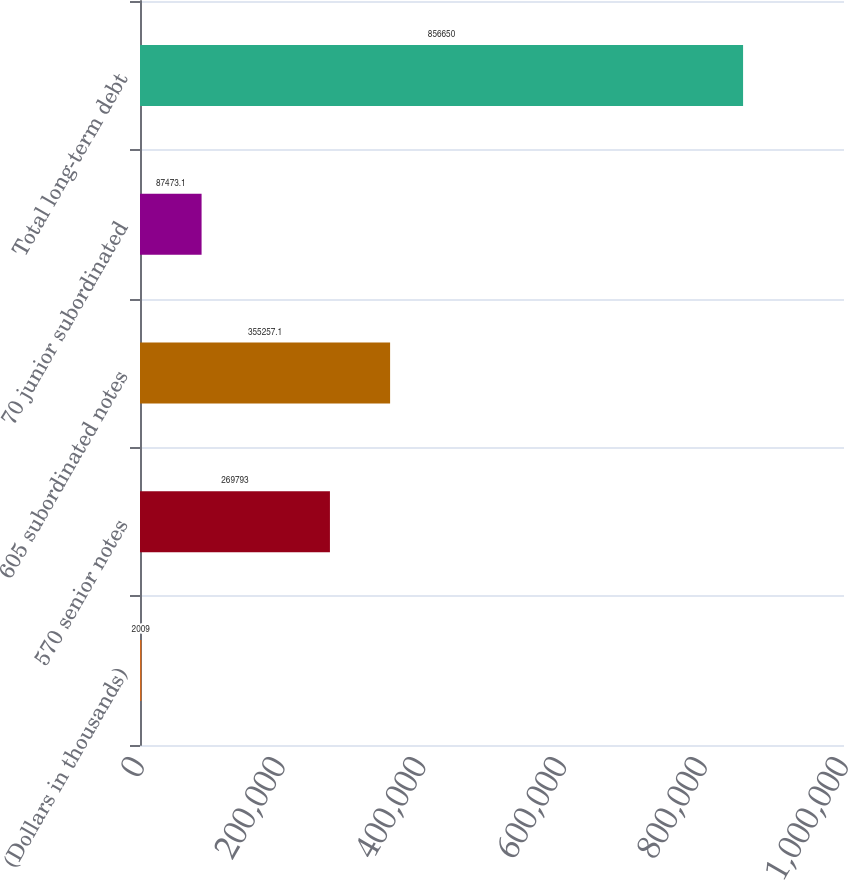Convert chart. <chart><loc_0><loc_0><loc_500><loc_500><bar_chart><fcel>(Dollars in thousands)<fcel>570 senior notes<fcel>605 subordinated notes<fcel>70 junior subordinated<fcel>Total long-term debt<nl><fcel>2009<fcel>269793<fcel>355257<fcel>87473.1<fcel>856650<nl></chart> 